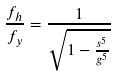Convert formula to latex. <formula><loc_0><loc_0><loc_500><loc_500>\frac { f _ { h } } { f _ { y } } = \frac { 1 } { \sqrt { 1 - \frac { s ^ { 5 } } { g ^ { 5 } } } }</formula> 